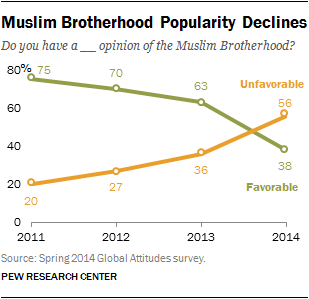Specify some key components in this picture. In 2013, the favorable to unfavorable rating of the Muslim Brotherhood was 0.57143. According to a survey conducted in the year 2012, the favourable percentage of the Muslim Brotherhood among respondents was 70%. 